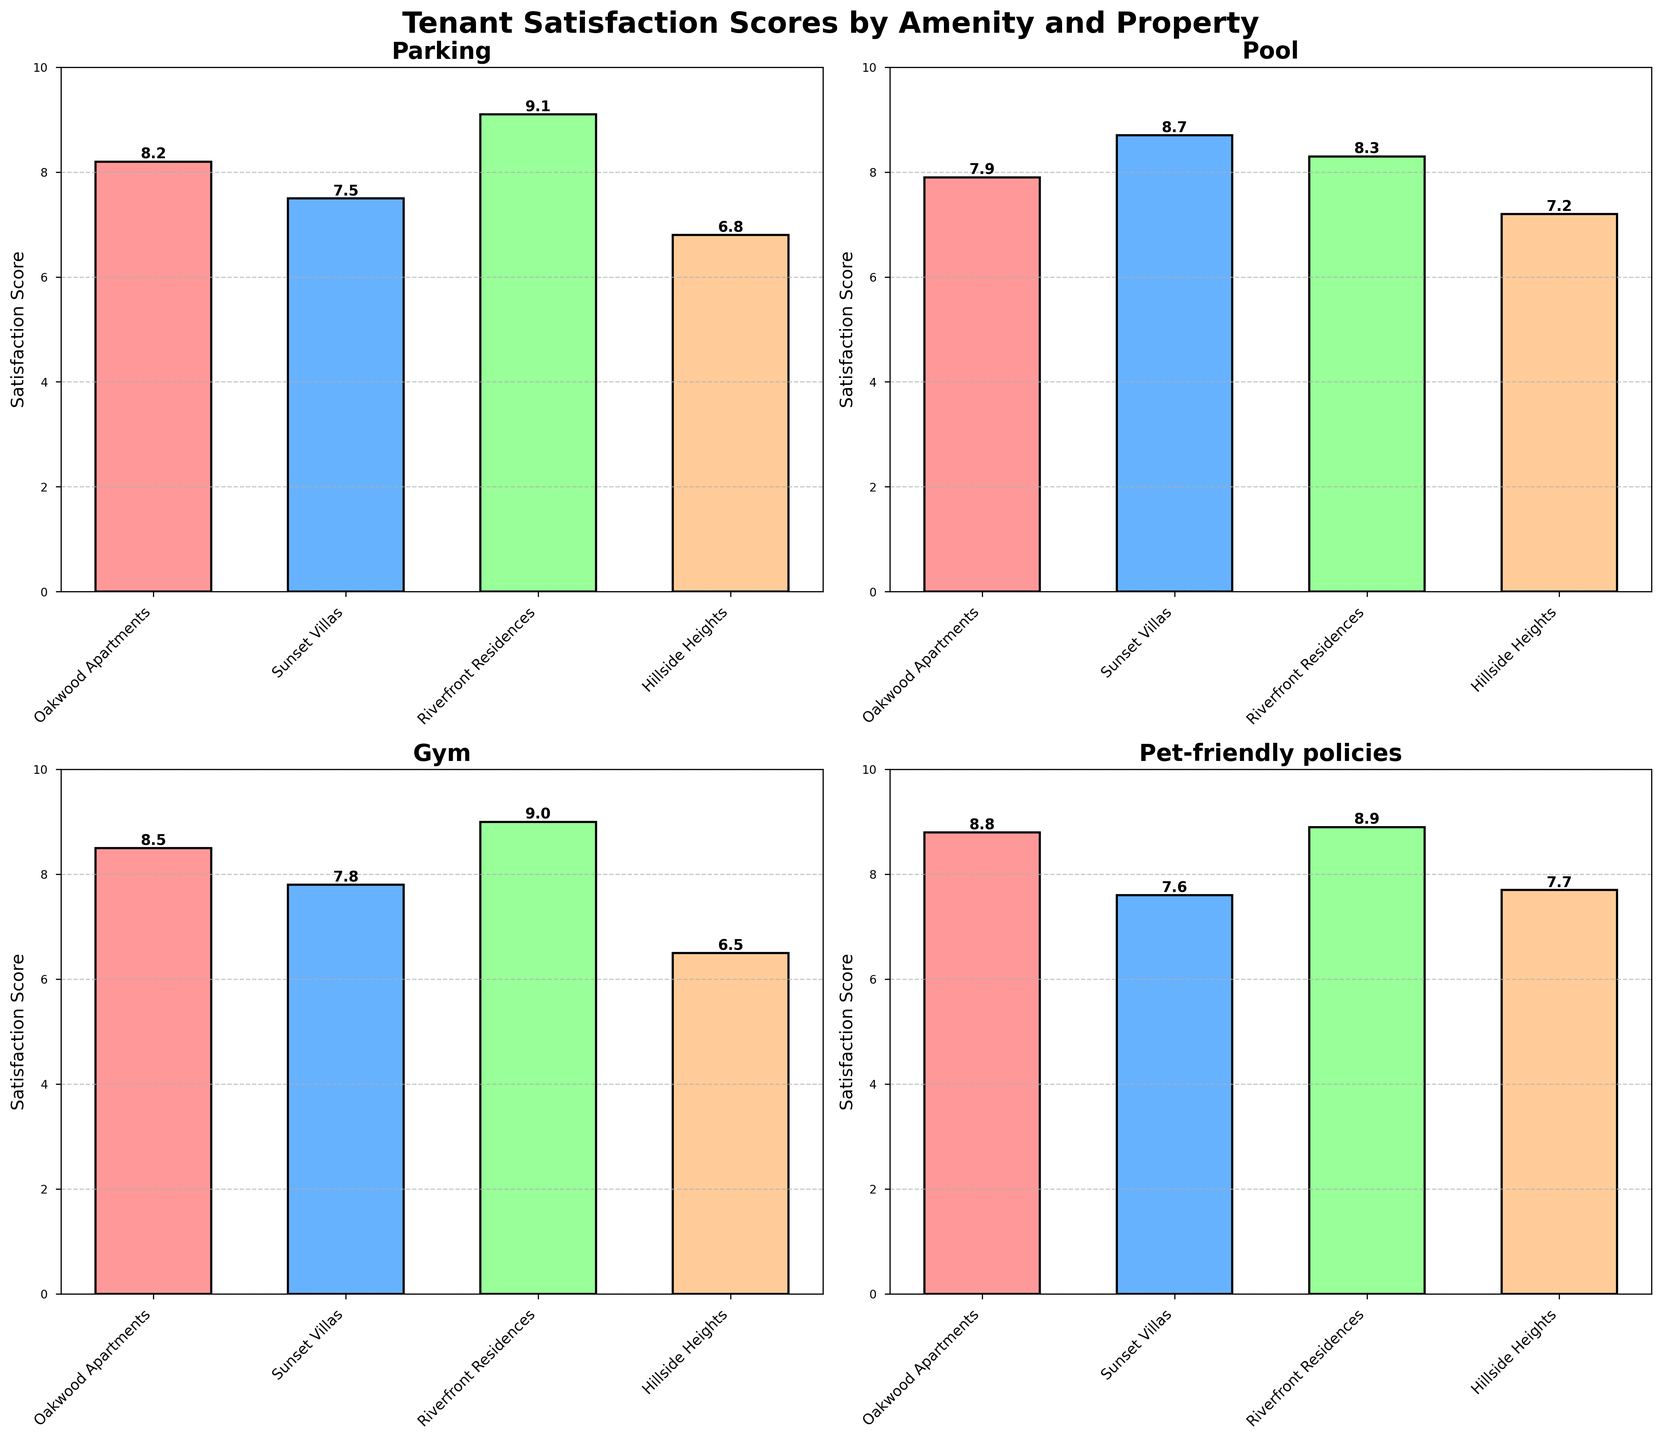what is the title of the figure? The title is usually displayed at the top of the figure and helps identify the main topic being visualized. Here, it's prominently placed and set in a larger, bold font.
Answer: Tenant Satisfaction Scores by Amenity and Property What property has the highest satisfaction score for the parking amenity? Look at the subplot titled "Parking" and identify the tallest bar in the chart. The property associated with this bar is "Riverfront Residences," with a score of 9.1.
Answer: Riverfront Residences What is the average satisfaction score for the pool amenity across all properties? First, identify the satisfaction scores for the pool amenity from each property: Oakwood Apartments (7.9), Sunset Villas (8.7), Riverfront Residences (8.3), and Hillside Heights (7.2). Then, calculate the average: (7.9 + 8.7 + 8.3 + 7.2) / 4 = 8.03
Answer: 8.03 What is the satisfaction score for Oakwood Apartments for the gym amenity? Examine the subplot titled "Gym" and find the bar associated with Oakwood Apartments. The satisfaction score is displayed at the top of the bar.
Answer: 8.5 Which property has the lowest satisfaction score for pet-friendly policies? Check the subplot titled "Pet-friendly policies." The shortest bar represents the property with the lowest score, which is "Sunset Villas."
Answer: Sunset Villas Between Oakwood Apartments and Sunset Villas, which property has a higher average satisfaction score across all amenities? First, find the satisfaction scores for each property across all amenities: Oakwood Apartments (Parking: 8.2, Pool: 7.9, Gym: 8.5, Pet-friendly policies: 8.8) and Sunset Villas (Parking: 7.5, Pool: 8.7, Gym: 7.8, Pet-friendly policies: 7.6). Then, calculate the average for each: Oakwood Apartments: (8.2 + 7.9 + 8.5 + 8.8)/4 = 8.35, Sunset Villas: (7.5 + 8.7 + 7.8 + 7.6)/4 = 7.9.
Answer: Oakwood Apartments How much higher is the satisfaction score for Riverfront Residences' parking compared to Hillside Heights' parking? Check the parking satisfaction scores for both properties: Riverfront Residences (9.1) and Hillside Heights (6.8). Calculate the difference: 9.1 - 6.8 = 2.3.
Answer: 2.3 Which amenity has the largest range of satisfaction scores across all properties? To find the range, subtract the smallest score from the largest score for each amenity: Parking (9.1 - 6.8 = 2.3), Pool (8.7 - 7.2 = 1.5), Gym (9.0 - 6.5 = 2.5), Pet-friendly policies (8.9 - 7.6 = 1.3). Compare these ranges. The gym has the largest range (2.5).
Answer: Gym Are there any properties that have the same satisfaction score for two different amenities? Check each property and its satisfaction scores for any duplicates: Oakwood Apartments (none), Sunset Villas (none), Riverfront Residences (none), Hillside Heights (none). No property has the same satisfaction score for two different amenities.
Answer: No 